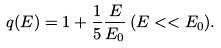Convert formula to latex. <formula><loc_0><loc_0><loc_500><loc_500>q ( E ) = 1 + \frac { 1 } { 5 } \frac { E } { E _ { 0 } } \, ( E < < E _ { 0 } ) .</formula> 